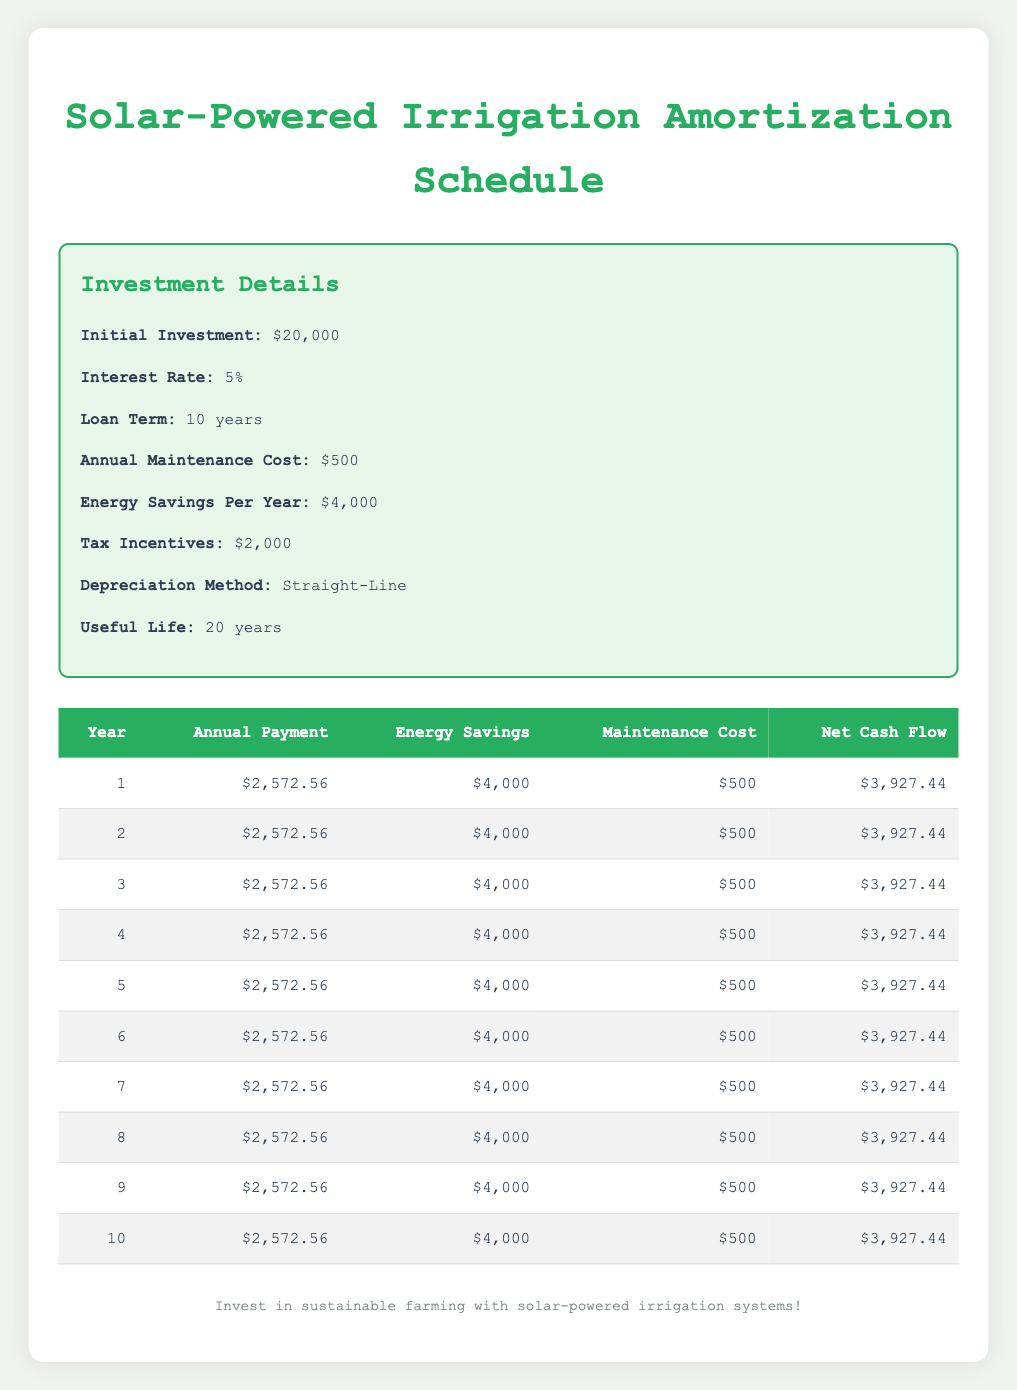What is the annual payment for the solar-powered irrigation system in year 1? The annual payment for each year is shown in the "Annual Payment" column of the table for year 1, which clearly states it as $2,572.56.
Answer: $2,572.56 How much are the total energy savings over the 10-year period? To find the total energy savings, multiply the annual energy savings of $4,000 by the number of years, which is 10 (4,000 * 10 = 40,000).
Answer: $40,000 Is the maintenance cost the same for each year? Looking at the "Maintenance Cost" column for all years, it consistently shows $500, indicating that the maintenance cost does not change year to year.
Answer: Yes What do you expect the net cash flow to be in year 5 compared to year 1? By comparing the "Net Cash Flow" column, we see both year 1 and year 5 have a net cash flow of $3,927.44, showing that they are identical throughout the years.
Answer: They are the same: $3,927.44 What is the average annual payment across the entire loan term? The average annual payment can be calculated by taking the total annual payment over 10 years, which is 2,572.56 multiplied by 10 (total $25,725.60), and dividing it by 10. Hence, average payment is 25,725.60/10 = 2,572.56.
Answer: $2,572.56 How much is the total cash flow after 10 years of investment? Total cash flow after 10 years can be calculated by summing each year's net cash flow which is $3,927.44 for ten years. So, 3,927.44 * 10 = 39,274.40.
Answer: $39,274.40 Is the depreciation method used for the system mentioned in the investment details? Yes, the investment details specify that the depreciation method is "Straight-Line", which is relevant information regarding the financial aspects of the system.
Answer: Yes What is the difference between total energy savings and total annual payments over 10 years? First, calculate the total energy savings, which is $40,000, and total annual payments, which is $25,725.60. Therefore, the difference is 40,000 - 25,725.60 = 14,274.40.
Answer: $14,274.40 What is the tax incentive given for this solar-powered irrigation system? The "Tax Incentives" section of the investment details states clearly that the incentive is $2,000.
Answer: $2,000 